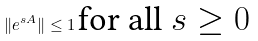<formula> <loc_0><loc_0><loc_500><loc_500>\| e ^ { s A } \| \leq 1 \, \text {for all $s\geq 0$}</formula> 